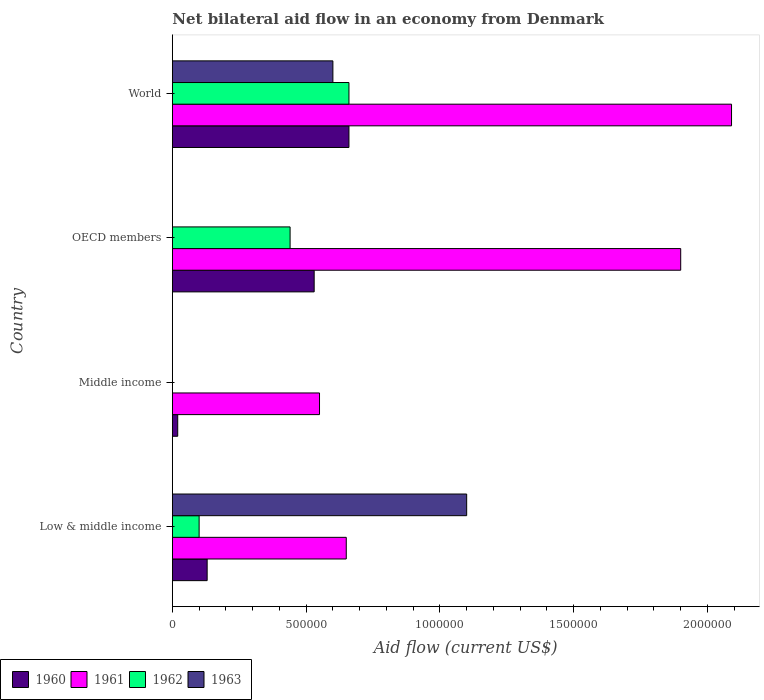How many different coloured bars are there?
Keep it short and to the point. 4. How many groups of bars are there?
Ensure brevity in your answer.  4. What is the label of the 3rd group of bars from the top?
Offer a very short reply. Middle income. What is the net bilateral aid flow in 1962 in World?
Your response must be concise. 6.60e+05. Across all countries, what is the minimum net bilateral aid flow in 1960?
Offer a terse response. 2.00e+04. What is the total net bilateral aid flow in 1961 in the graph?
Your answer should be very brief. 5.19e+06. What is the difference between the net bilateral aid flow in 1962 in OECD members and that in World?
Give a very brief answer. -2.20e+05. What is the difference between the net bilateral aid flow in 1960 in OECD members and the net bilateral aid flow in 1962 in Middle income?
Make the answer very short. 5.30e+05. What is the average net bilateral aid flow in 1962 per country?
Your answer should be very brief. 3.00e+05. In how many countries, is the net bilateral aid flow in 1962 greater than 1300000 US$?
Your answer should be very brief. 0. What is the ratio of the net bilateral aid flow in 1961 in Low & middle income to that in OECD members?
Offer a very short reply. 0.34. Is the difference between the net bilateral aid flow in 1960 in Low & middle income and OECD members greater than the difference between the net bilateral aid flow in 1962 in Low & middle income and OECD members?
Ensure brevity in your answer.  No. What is the difference between the highest and the second highest net bilateral aid flow in 1962?
Provide a short and direct response. 2.20e+05. In how many countries, is the net bilateral aid flow in 1961 greater than the average net bilateral aid flow in 1961 taken over all countries?
Your answer should be compact. 2. Is the sum of the net bilateral aid flow in 1963 in Low & middle income and World greater than the maximum net bilateral aid flow in 1960 across all countries?
Offer a very short reply. Yes. Is it the case that in every country, the sum of the net bilateral aid flow in 1960 and net bilateral aid flow in 1962 is greater than the sum of net bilateral aid flow in 1963 and net bilateral aid flow in 1961?
Give a very brief answer. No. How many bars are there?
Provide a short and direct response. 13. How many countries are there in the graph?
Make the answer very short. 4. Are the values on the major ticks of X-axis written in scientific E-notation?
Offer a terse response. No. Does the graph contain grids?
Your answer should be compact. No. How many legend labels are there?
Provide a short and direct response. 4. How are the legend labels stacked?
Your response must be concise. Horizontal. What is the title of the graph?
Your answer should be compact. Net bilateral aid flow in an economy from Denmark. Does "1973" appear as one of the legend labels in the graph?
Your response must be concise. No. What is the Aid flow (current US$) of 1960 in Low & middle income?
Your response must be concise. 1.30e+05. What is the Aid flow (current US$) of 1961 in Low & middle income?
Keep it short and to the point. 6.50e+05. What is the Aid flow (current US$) of 1962 in Low & middle income?
Provide a short and direct response. 1.00e+05. What is the Aid flow (current US$) of 1963 in Low & middle income?
Provide a succinct answer. 1.10e+06. What is the Aid flow (current US$) of 1960 in OECD members?
Your answer should be compact. 5.30e+05. What is the Aid flow (current US$) of 1961 in OECD members?
Your answer should be very brief. 1.90e+06. What is the Aid flow (current US$) in 1961 in World?
Give a very brief answer. 2.09e+06. What is the Aid flow (current US$) in 1962 in World?
Keep it short and to the point. 6.60e+05. What is the Aid flow (current US$) of 1963 in World?
Offer a very short reply. 6.00e+05. Across all countries, what is the maximum Aid flow (current US$) of 1961?
Offer a terse response. 2.09e+06. Across all countries, what is the maximum Aid flow (current US$) in 1963?
Your response must be concise. 1.10e+06. Across all countries, what is the minimum Aid flow (current US$) in 1961?
Provide a succinct answer. 5.50e+05. What is the total Aid flow (current US$) of 1960 in the graph?
Your response must be concise. 1.34e+06. What is the total Aid flow (current US$) of 1961 in the graph?
Keep it short and to the point. 5.19e+06. What is the total Aid flow (current US$) in 1962 in the graph?
Your answer should be very brief. 1.20e+06. What is the total Aid flow (current US$) in 1963 in the graph?
Give a very brief answer. 1.70e+06. What is the difference between the Aid flow (current US$) in 1960 in Low & middle income and that in Middle income?
Keep it short and to the point. 1.10e+05. What is the difference between the Aid flow (current US$) of 1961 in Low & middle income and that in Middle income?
Make the answer very short. 1.00e+05. What is the difference between the Aid flow (current US$) of 1960 in Low & middle income and that in OECD members?
Offer a very short reply. -4.00e+05. What is the difference between the Aid flow (current US$) in 1961 in Low & middle income and that in OECD members?
Keep it short and to the point. -1.25e+06. What is the difference between the Aid flow (current US$) in 1960 in Low & middle income and that in World?
Give a very brief answer. -5.30e+05. What is the difference between the Aid flow (current US$) in 1961 in Low & middle income and that in World?
Offer a very short reply. -1.44e+06. What is the difference between the Aid flow (current US$) in 1962 in Low & middle income and that in World?
Offer a very short reply. -5.60e+05. What is the difference between the Aid flow (current US$) of 1963 in Low & middle income and that in World?
Provide a succinct answer. 5.00e+05. What is the difference between the Aid flow (current US$) of 1960 in Middle income and that in OECD members?
Provide a succinct answer. -5.10e+05. What is the difference between the Aid flow (current US$) in 1961 in Middle income and that in OECD members?
Your answer should be very brief. -1.35e+06. What is the difference between the Aid flow (current US$) in 1960 in Middle income and that in World?
Ensure brevity in your answer.  -6.40e+05. What is the difference between the Aid flow (current US$) in 1961 in Middle income and that in World?
Give a very brief answer. -1.54e+06. What is the difference between the Aid flow (current US$) of 1960 in OECD members and that in World?
Ensure brevity in your answer.  -1.30e+05. What is the difference between the Aid flow (current US$) in 1960 in Low & middle income and the Aid flow (current US$) in 1961 in Middle income?
Your answer should be compact. -4.20e+05. What is the difference between the Aid flow (current US$) in 1960 in Low & middle income and the Aid flow (current US$) in 1961 in OECD members?
Your answer should be very brief. -1.77e+06. What is the difference between the Aid flow (current US$) in 1960 in Low & middle income and the Aid flow (current US$) in 1962 in OECD members?
Provide a short and direct response. -3.10e+05. What is the difference between the Aid flow (current US$) of 1961 in Low & middle income and the Aid flow (current US$) of 1962 in OECD members?
Give a very brief answer. 2.10e+05. What is the difference between the Aid flow (current US$) in 1960 in Low & middle income and the Aid flow (current US$) in 1961 in World?
Provide a short and direct response. -1.96e+06. What is the difference between the Aid flow (current US$) in 1960 in Low & middle income and the Aid flow (current US$) in 1962 in World?
Offer a terse response. -5.30e+05. What is the difference between the Aid flow (current US$) in 1960 in Low & middle income and the Aid flow (current US$) in 1963 in World?
Ensure brevity in your answer.  -4.70e+05. What is the difference between the Aid flow (current US$) in 1961 in Low & middle income and the Aid flow (current US$) in 1962 in World?
Provide a short and direct response. -10000. What is the difference between the Aid flow (current US$) in 1962 in Low & middle income and the Aid flow (current US$) in 1963 in World?
Give a very brief answer. -5.00e+05. What is the difference between the Aid flow (current US$) of 1960 in Middle income and the Aid flow (current US$) of 1961 in OECD members?
Provide a short and direct response. -1.88e+06. What is the difference between the Aid flow (current US$) in 1960 in Middle income and the Aid flow (current US$) in 1962 in OECD members?
Provide a succinct answer. -4.20e+05. What is the difference between the Aid flow (current US$) of 1960 in Middle income and the Aid flow (current US$) of 1961 in World?
Ensure brevity in your answer.  -2.07e+06. What is the difference between the Aid flow (current US$) of 1960 in Middle income and the Aid flow (current US$) of 1962 in World?
Offer a terse response. -6.40e+05. What is the difference between the Aid flow (current US$) in 1960 in Middle income and the Aid flow (current US$) in 1963 in World?
Provide a short and direct response. -5.80e+05. What is the difference between the Aid flow (current US$) of 1961 in Middle income and the Aid flow (current US$) of 1962 in World?
Give a very brief answer. -1.10e+05. What is the difference between the Aid flow (current US$) in 1960 in OECD members and the Aid flow (current US$) in 1961 in World?
Make the answer very short. -1.56e+06. What is the difference between the Aid flow (current US$) of 1960 in OECD members and the Aid flow (current US$) of 1962 in World?
Ensure brevity in your answer.  -1.30e+05. What is the difference between the Aid flow (current US$) of 1960 in OECD members and the Aid flow (current US$) of 1963 in World?
Your answer should be compact. -7.00e+04. What is the difference between the Aid flow (current US$) in 1961 in OECD members and the Aid flow (current US$) in 1962 in World?
Offer a terse response. 1.24e+06. What is the difference between the Aid flow (current US$) in 1961 in OECD members and the Aid flow (current US$) in 1963 in World?
Keep it short and to the point. 1.30e+06. What is the average Aid flow (current US$) of 1960 per country?
Offer a very short reply. 3.35e+05. What is the average Aid flow (current US$) of 1961 per country?
Offer a terse response. 1.30e+06. What is the average Aid flow (current US$) in 1962 per country?
Provide a succinct answer. 3.00e+05. What is the average Aid flow (current US$) in 1963 per country?
Offer a very short reply. 4.25e+05. What is the difference between the Aid flow (current US$) in 1960 and Aid flow (current US$) in 1961 in Low & middle income?
Your answer should be compact. -5.20e+05. What is the difference between the Aid flow (current US$) of 1960 and Aid flow (current US$) of 1962 in Low & middle income?
Your answer should be compact. 3.00e+04. What is the difference between the Aid flow (current US$) in 1960 and Aid flow (current US$) in 1963 in Low & middle income?
Give a very brief answer. -9.70e+05. What is the difference between the Aid flow (current US$) of 1961 and Aid flow (current US$) of 1963 in Low & middle income?
Provide a succinct answer. -4.50e+05. What is the difference between the Aid flow (current US$) in 1962 and Aid flow (current US$) in 1963 in Low & middle income?
Make the answer very short. -1.00e+06. What is the difference between the Aid flow (current US$) in 1960 and Aid flow (current US$) in 1961 in Middle income?
Make the answer very short. -5.30e+05. What is the difference between the Aid flow (current US$) of 1960 and Aid flow (current US$) of 1961 in OECD members?
Provide a short and direct response. -1.37e+06. What is the difference between the Aid flow (current US$) of 1961 and Aid flow (current US$) of 1962 in OECD members?
Offer a terse response. 1.46e+06. What is the difference between the Aid flow (current US$) of 1960 and Aid flow (current US$) of 1961 in World?
Your answer should be very brief. -1.43e+06. What is the difference between the Aid flow (current US$) in 1961 and Aid flow (current US$) in 1962 in World?
Give a very brief answer. 1.43e+06. What is the difference between the Aid flow (current US$) in 1961 and Aid flow (current US$) in 1963 in World?
Provide a succinct answer. 1.49e+06. What is the difference between the Aid flow (current US$) in 1962 and Aid flow (current US$) in 1963 in World?
Offer a very short reply. 6.00e+04. What is the ratio of the Aid flow (current US$) in 1960 in Low & middle income to that in Middle income?
Keep it short and to the point. 6.5. What is the ratio of the Aid flow (current US$) in 1961 in Low & middle income to that in Middle income?
Give a very brief answer. 1.18. What is the ratio of the Aid flow (current US$) of 1960 in Low & middle income to that in OECD members?
Ensure brevity in your answer.  0.25. What is the ratio of the Aid flow (current US$) in 1961 in Low & middle income to that in OECD members?
Provide a succinct answer. 0.34. What is the ratio of the Aid flow (current US$) in 1962 in Low & middle income to that in OECD members?
Your answer should be very brief. 0.23. What is the ratio of the Aid flow (current US$) in 1960 in Low & middle income to that in World?
Keep it short and to the point. 0.2. What is the ratio of the Aid flow (current US$) in 1961 in Low & middle income to that in World?
Make the answer very short. 0.31. What is the ratio of the Aid flow (current US$) of 1962 in Low & middle income to that in World?
Your response must be concise. 0.15. What is the ratio of the Aid flow (current US$) in 1963 in Low & middle income to that in World?
Provide a short and direct response. 1.83. What is the ratio of the Aid flow (current US$) of 1960 in Middle income to that in OECD members?
Offer a terse response. 0.04. What is the ratio of the Aid flow (current US$) in 1961 in Middle income to that in OECD members?
Your answer should be compact. 0.29. What is the ratio of the Aid flow (current US$) in 1960 in Middle income to that in World?
Offer a very short reply. 0.03. What is the ratio of the Aid flow (current US$) in 1961 in Middle income to that in World?
Offer a terse response. 0.26. What is the ratio of the Aid flow (current US$) in 1960 in OECD members to that in World?
Your response must be concise. 0.8. What is the ratio of the Aid flow (current US$) in 1961 in OECD members to that in World?
Give a very brief answer. 0.91. What is the ratio of the Aid flow (current US$) in 1962 in OECD members to that in World?
Offer a very short reply. 0.67. What is the difference between the highest and the second highest Aid flow (current US$) of 1960?
Your answer should be very brief. 1.30e+05. What is the difference between the highest and the second highest Aid flow (current US$) of 1962?
Provide a succinct answer. 2.20e+05. What is the difference between the highest and the lowest Aid flow (current US$) in 1960?
Provide a short and direct response. 6.40e+05. What is the difference between the highest and the lowest Aid flow (current US$) of 1961?
Offer a terse response. 1.54e+06. What is the difference between the highest and the lowest Aid flow (current US$) in 1962?
Give a very brief answer. 6.60e+05. What is the difference between the highest and the lowest Aid flow (current US$) in 1963?
Give a very brief answer. 1.10e+06. 